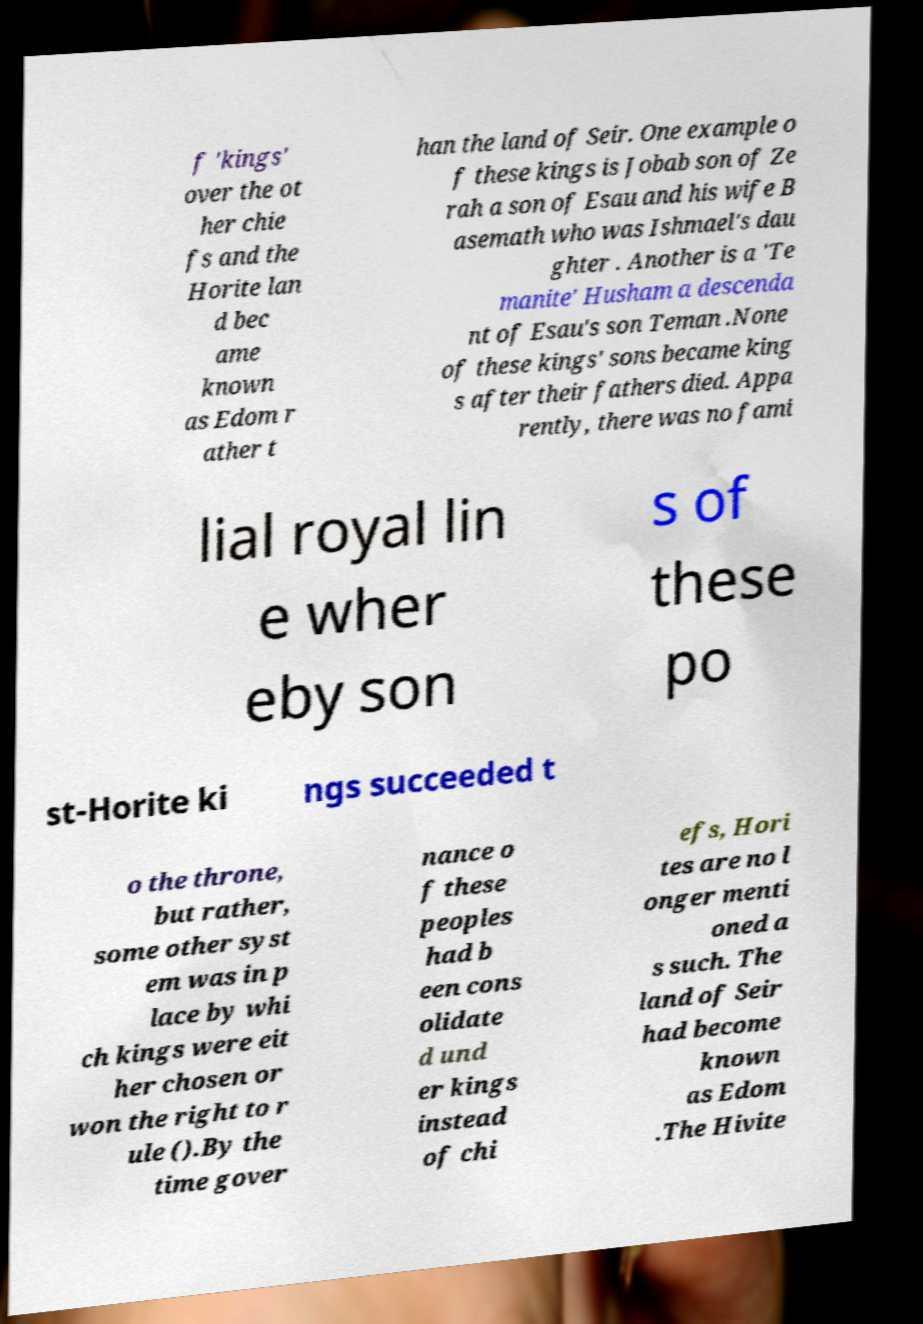Please identify and transcribe the text found in this image. f 'kings' over the ot her chie fs and the Horite lan d bec ame known as Edom r ather t han the land of Seir. One example o f these kings is Jobab son of Ze rah a son of Esau and his wife B asemath who was Ishmael's dau ghter . Another is a 'Te manite' Husham a descenda nt of Esau's son Teman .None of these kings' sons became king s after their fathers died. Appa rently, there was no fami lial royal lin e wher eby son s of these po st-Horite ki ngs succeeded t o the throne, but rather, some other syst em was in p lace by whi ch kings were eit her chosen or won the right to r ule ().By the time gover nance o f these peoples had b een cons olidate d und er kings instead of chi efs, Hori tes are no l onger menti oned a s such. The land of Seir had become known as Edom .The Hivite 